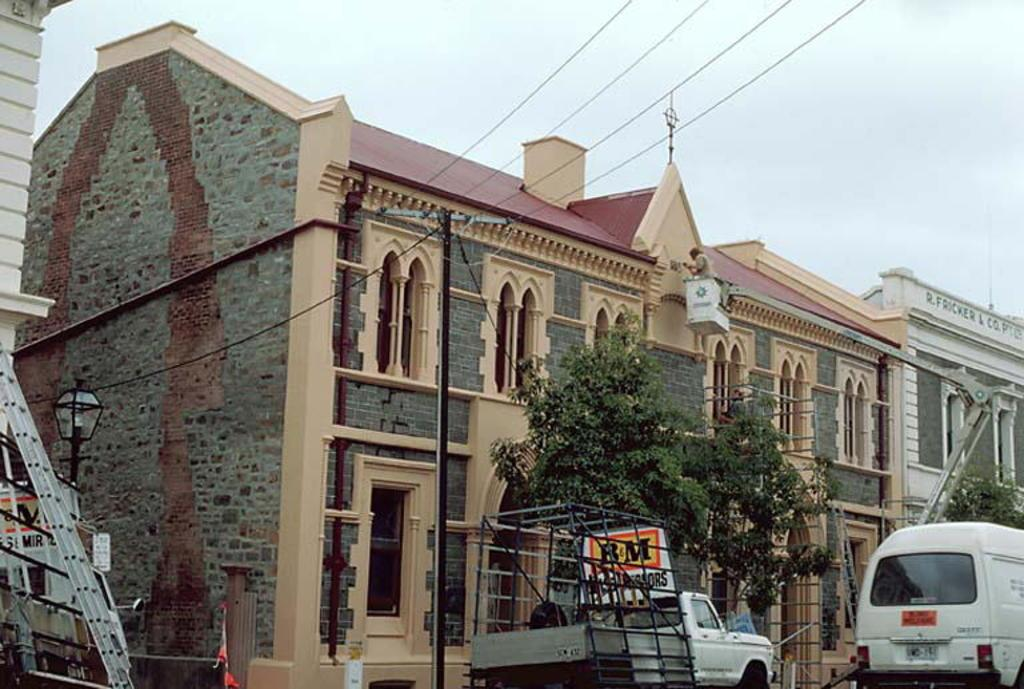What can be seen on the road at the bottom of the image? There are vehicles on the road at the bottom of the image. What type of natural elements are present in the image? There are trees in the image. What type of man-made structures can be seen in the background? There are buildings in the background of the image. What other objects can be seen in the background? There are poles and wires in the background of the image. What is visible at the top of the image? The sky is visible at the top of the image. When was the image taken? The image was taken during the day. Can you see any fairies playing a guitar on a hill in the image? There are no fairies, guitars, or hills present in the image. 